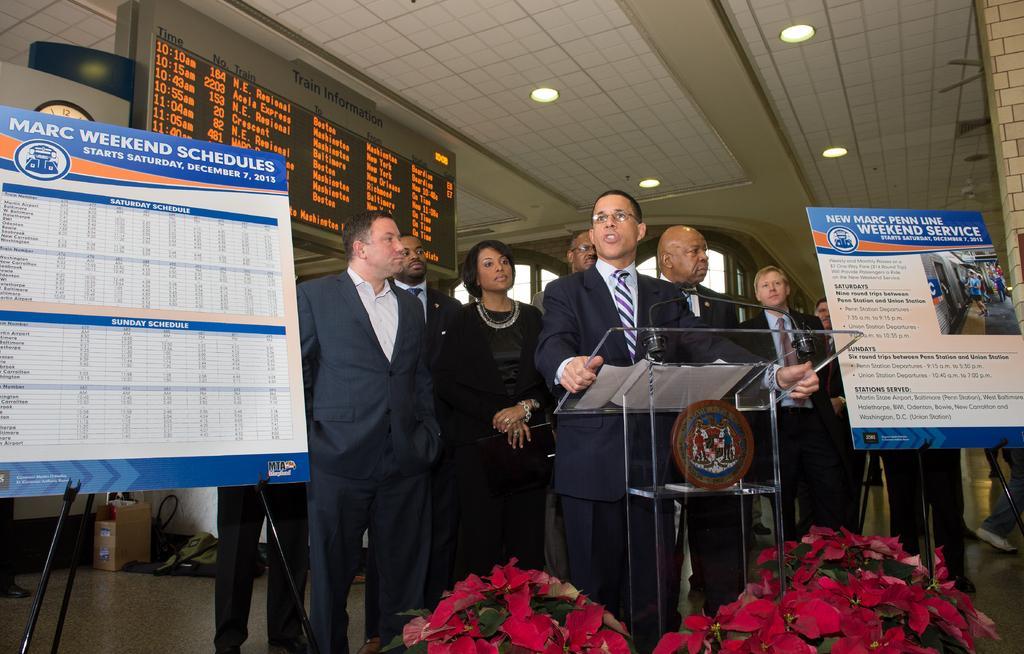How would you summarize this image in a sentence or two? In this image there are many people standing. Also there is a stand with mics. And there is an emblem. At the bottom there are flower bouquets. There are boards with stands. On the ceiling there are lights. In the background there is a screen with something written. On the ground there is a cardboard box and some other things. 